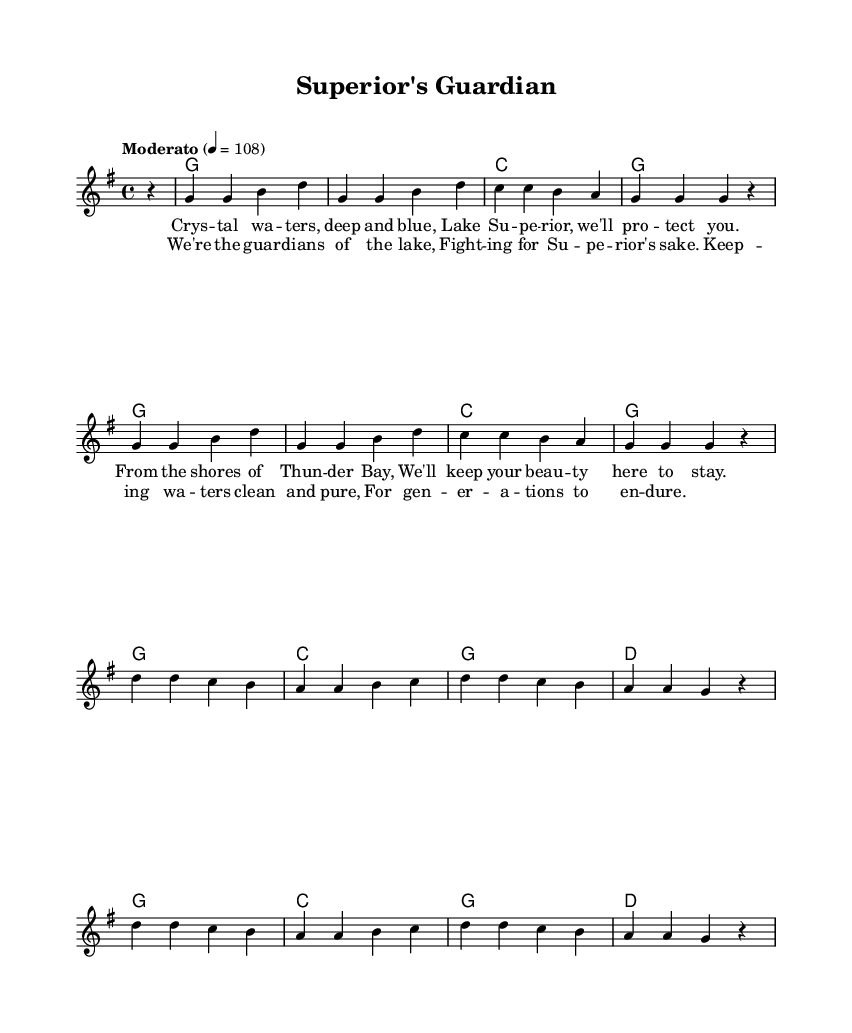What is the key signature of this music? The music is set in G major, which has one sharp (F#). This can be identified by looking at the beginning of the staff where the key signature is displayed.
Answer: G major What is the time signature of this music? The time signature shown at the beginning is 4/4, meaning there are four beats in each measure, and a quarter note receives one beat. This is indicated by the numbers after the time signature notation.
Answer: 4/4 What is the tempo marking for this piece? The tempo marking indicates "Moderato" with a metronome marking of 108 beats per minute. This is displayed above the staff and informs the performer about the speed of the piece.
Answer: Moderato How many verses are there in this song? The song has one verse followed by a chorus, as indicated by the lyric sections. The lyrics for "verseOne" are distinct and are provided before the chorus lyrics.
Answer: One What is the last note of the melody in the chorus? The last note in the melody corresponding to the chorus is a g note, as found at the end of the "chorus" lyrics section, which syncs with the last syllable of the text.
Answer: g How many measures does the verse consist of? The verse is composed of four measures, as can be counted from the melody notation provided above the lyrics. Each measure is separated by vertical lines, and there are four groupings of notes for "verseOne."
Answer: Four What is the purpose of the song based on its lyrics? The song is aimed at raising awareness and promoting the protection of Lake Superior and its beauty, as expressed in the lyrics regarding guardianship and keeping the waters clean. This can be inferred from the message conveyed throughout the verses and chorus.
Answer: Protecting Lake Superior 